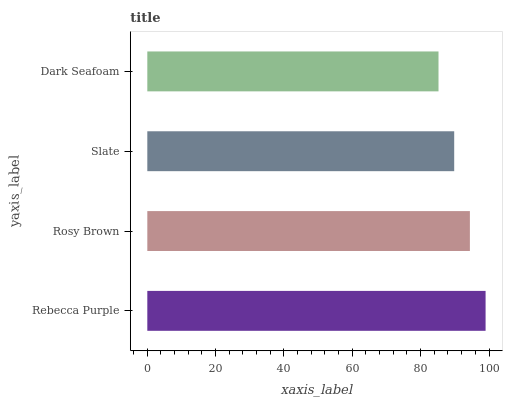Is Dark Seafoam the minimum?
Answer yes or no. Yes. Is Rebecca Purple the maximum?
Answer yes or no. Yes. Is Rosy Brown the minimum?
Answer yes or no. No. Is Rosy Brown the maximum?
Answer yes or no. No. Is Rebecca Purple greater than Rosy Brown?
Answer yes or no. Yes. Is Rosy Brown less than Rebecca Purple?
Answer yes or no. Yes. Is Rosy Brown greater than Rebecca Purple?
Answer yes or no. No. Is Rebecca Purple less than Rosy Brown?
Answer yes or no. No. Is Rosy Brown the high median?
Answer yes or no. Yes. Is Slate the low median?
Answer yes or no. Yes. Is Slate the high median?
Answer yes or no. No. Is Dark Seafoam the low median?
Answer yes or no. No. 